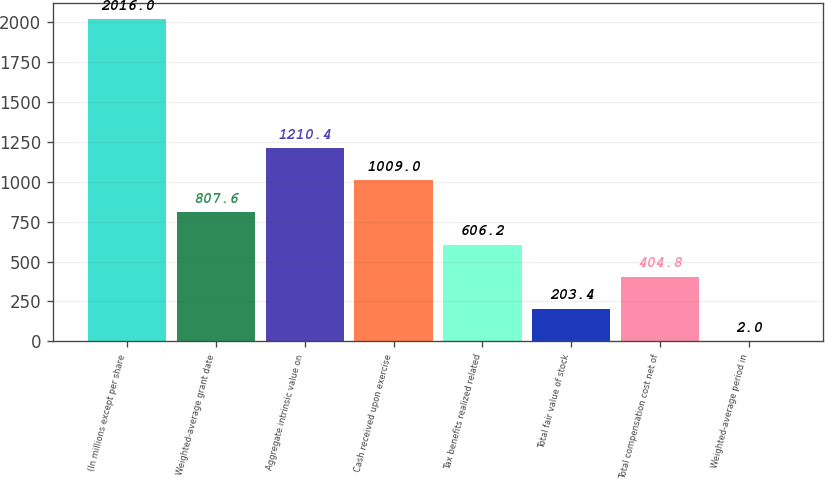Convert chart to OTSL. <chart><loc_0><loc_0><loc_500><loc_500><bar_chart><fcel>(In millions except per share<fcel>Weighted-average grant date<fcel>Aggregate intrinsic value on<fcel>Cash received upon exercise<fcel>Tax benefits realized related<fcel>Total fair value of stock<fcel>Total compensation cost net of<fcel>Weighted-average period in<nl><fcel>2016<fcel>807.6<fcel>1210.4<fcel>1009<fcel>606.2<fcel>203.4<fcel>404.8<fcel>2<nl></chart> 